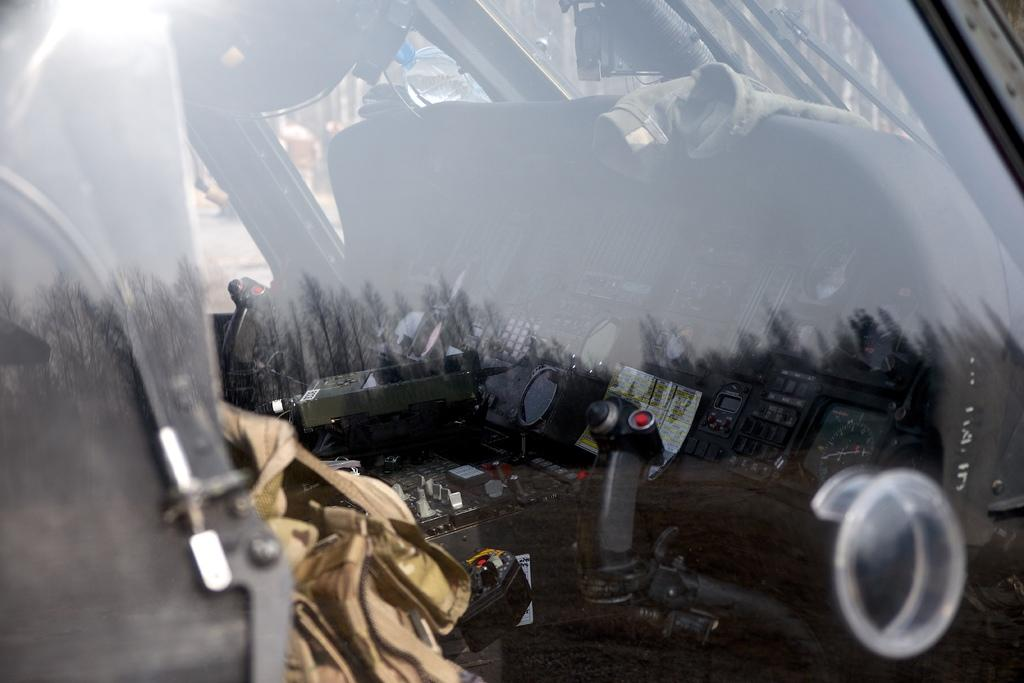What is the main subject of the image? The main subject of the image is an aircraft. How is the aircraft depicted in the image? The aircraft appears to be truncated in the image. What can be seen through the glass of the aircraft? Through the glass, we can see a control stick, gauges, cloth, a bottle, and other parts of the aircraft's interior. What type of square object can be seen expanding in the image? There is no square object present in the image, nor is there any indication of expansion. 